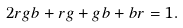Convert formula to latex. <formula><loc_0><loc_0><loc_500><loc_500>2 r g b + r g + g b + b r = 1 .</formula> 